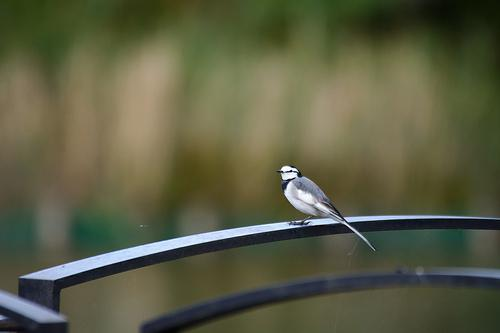Question: who is featured in this photo?
Choices:
A. A man.
B. A bird.
C. A squirrel.
D. A woman.
Answer with the letter. Answer: B 